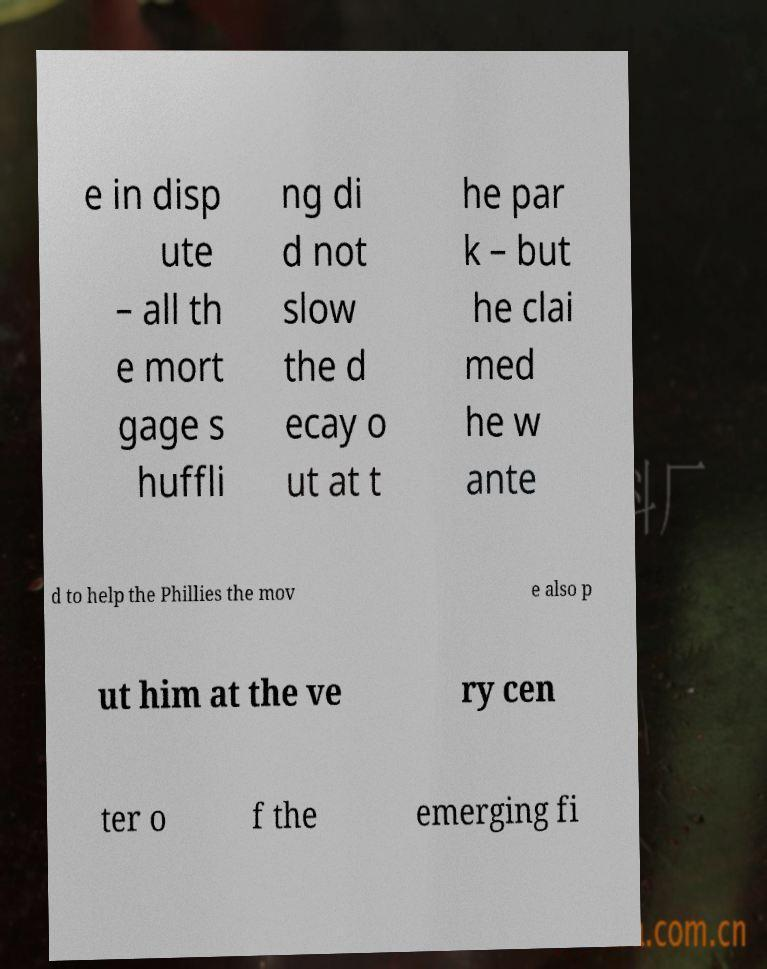For documentation purposes, I need the text within this image transcribed. Could you provide that? e in disp ute – all th e mort gage s huffli ng di d not slow the d ecay o ut at t he par k – but he clai med he w ante d to help the Phillies the mov e also p ut him at the ve ry cen ter o f the emerging fi 